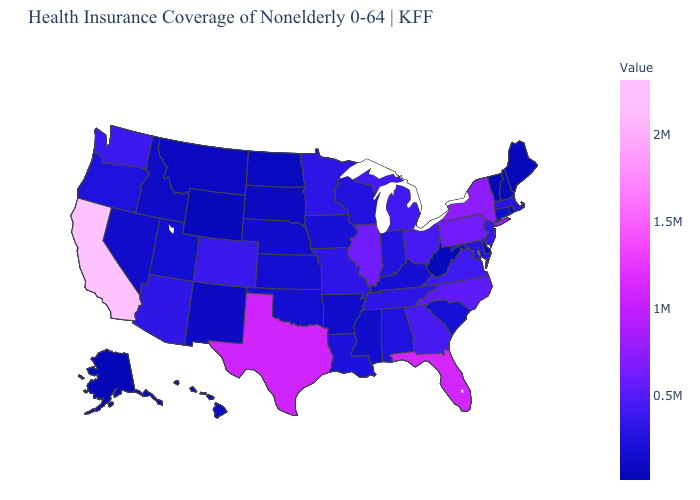Which states have the highest value in the USA?
Quick response, please. California. Does Louisiana have the highest value in the South?
Keep it brief. No. Does Rhode Island have the highest value in the USA?
Answer briefly. No. Does Michigan have a lower value than New York?
Keep it brief. Yes. Does North Dakota have the lowest value in the MidWest?
Answer briefly. Yes. Which states have the lowest value in the MidWest?
Answer briefly. North Dakota. 